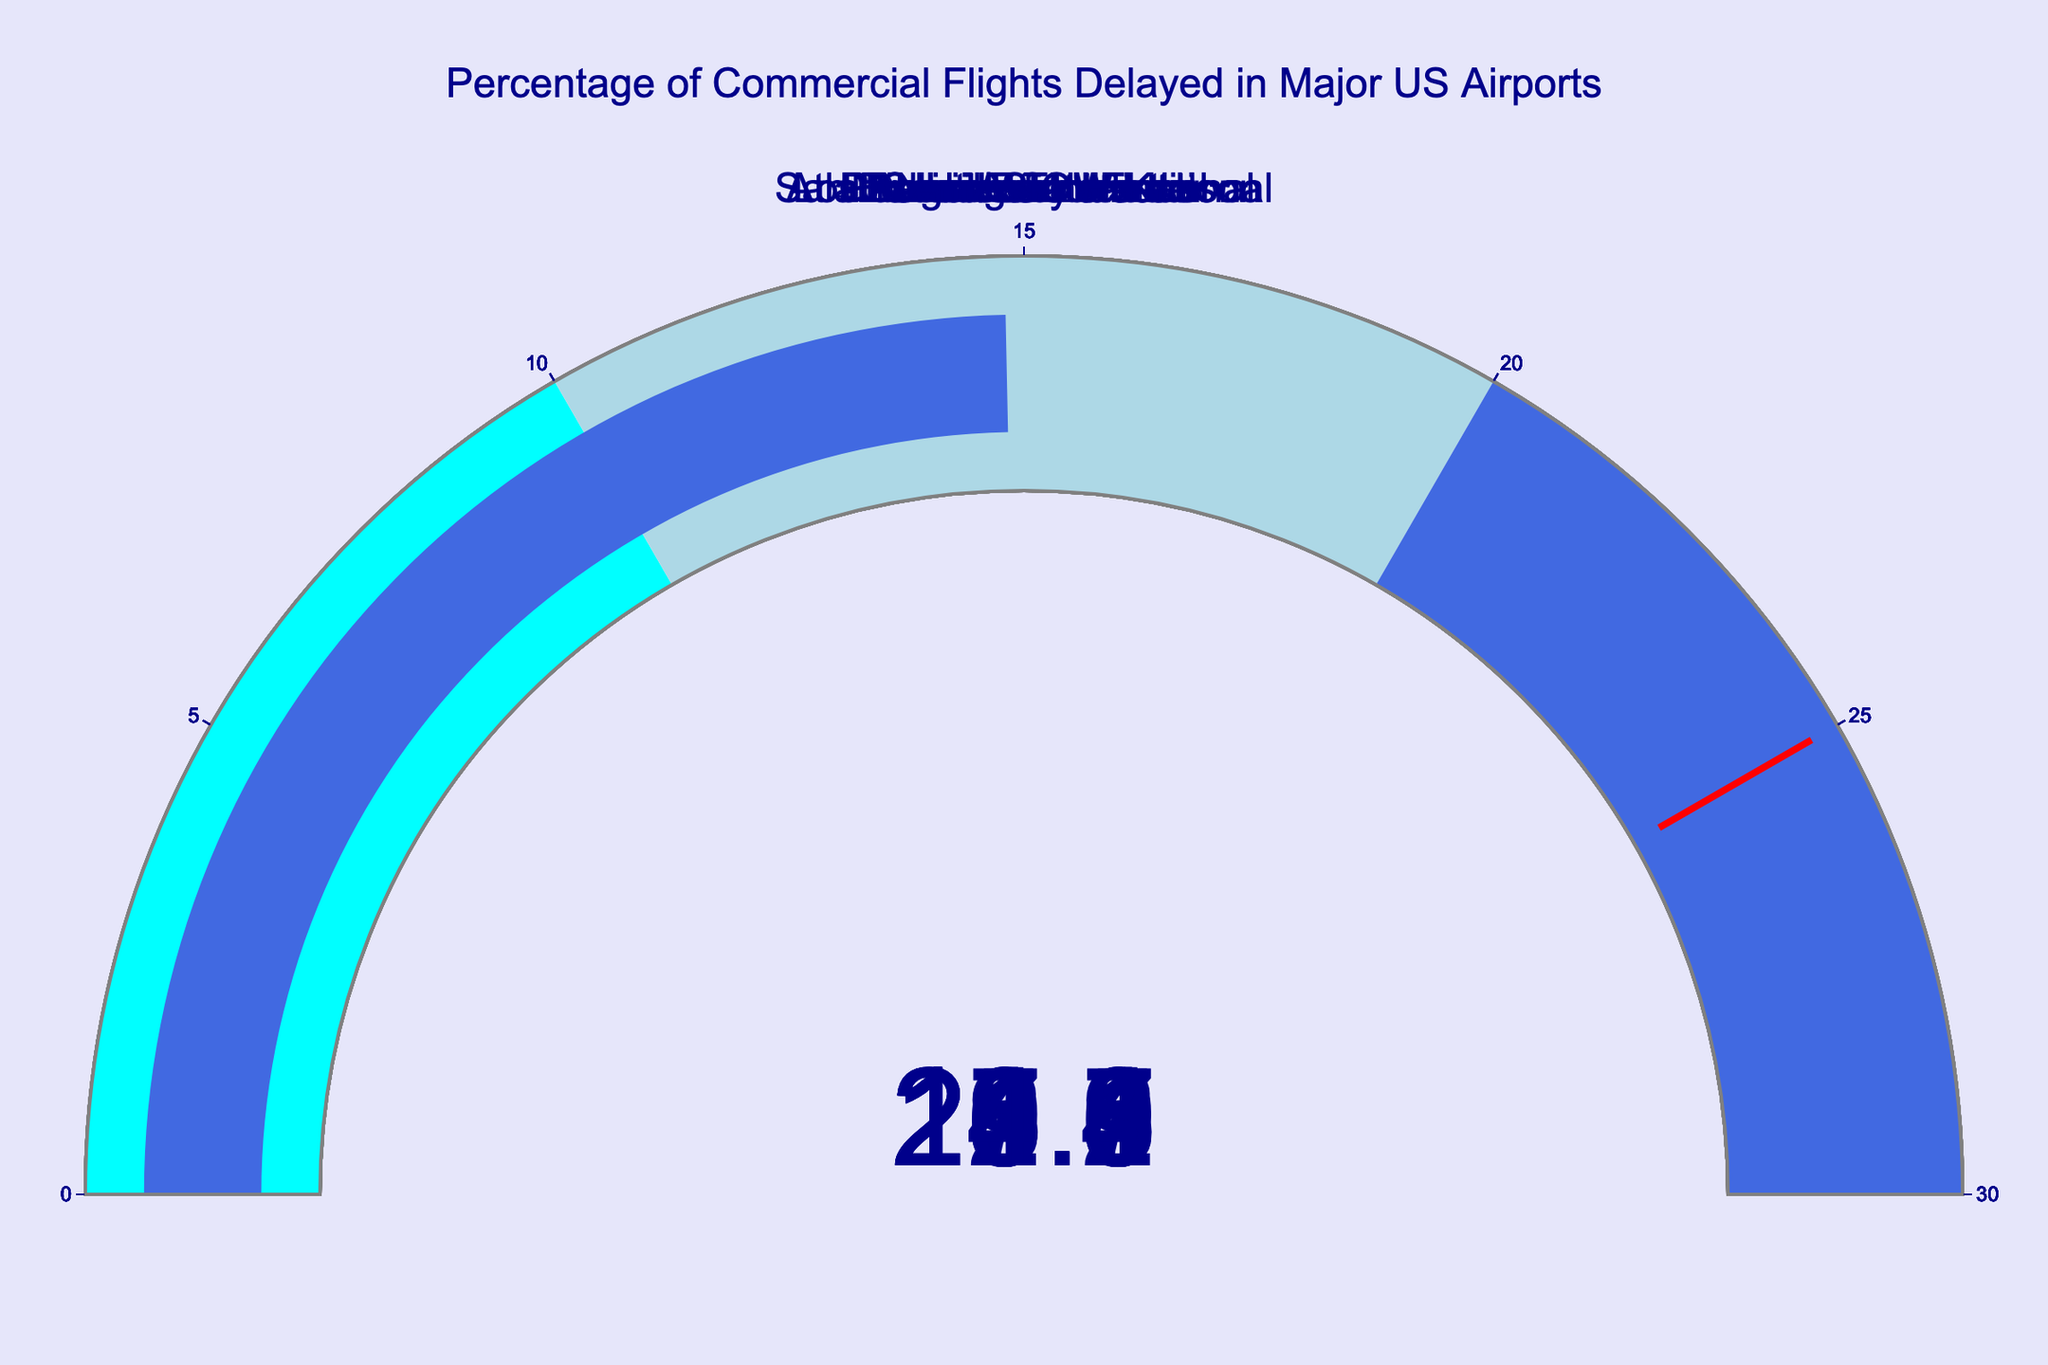What's the title of the chart? The title is prominently displayed above the gauges and indicates the overall topic of the chart. The text is "Percentage of Commercial Flights Delayed in Major US Airports" as shown in the title section of the figure.
Answer: Percentage of Commercial Flights Delayed in Major US Airports How many airports are represented in the chart? There are gauges for each airport, and you can count them directly from the figure. Each gauge represents one airport. By counting these gauges, you find there are 10 airports.
Answer: 10 Which airport has the highest percentage of delays? By looking at all the gauges, you can identify the highest value displayed on any gauge. The highest percentage shown is 23.6%, which corresponds to New York JFK.
Answer: New York JFK Which airport has the lowest percentage of delays? Similar to the previous question, observe all the gauges and identify the lowest value displayed. The lowest percentage is 14.8%, which belongs to Phoenix Sky Harbor.
Answer: Phoenix Sky Harbor What is the average delay percentage across all the airports? To find the average, sum the delay percentages of all 10 airports and then divide by 10. The total is 18.5 + 22.3 + 15.7 + 19.8 + 17.2 + 20.1 + 23.6 + 16.4 + 21.9 + 14.8 = 190.3. So the average is 190.3 / 10 = 19.03.
Answer: 19.03 How many airports have delay percentages above 20%? Identify each gauge that shows a delay percentage greater than 20%. These include Chicago O'Hare (22.3%), San Francisco International (20.1%), New York JFK (23.6%), and Miami International (21.9%). There are 4 such airports.
Answer: 4 What is the range of delay percentages observed in the chart? The range is calculated by finding the difference between the maximum and minimum delay percentages. The maximum is 23.6% (New York JFK) and the minimum is 14.8% (Phoenix Sky Harbor). So the range is 23.6% - 14.8% = 8.8%.
Answer: 8.8% Which airports have a delay percentage closest to the average? First calculate the average delay percentage (19.03%). Then, find the airport(s) whose delays are closest to this average. Denver International has a delay percentage of 17.2%, and Dallas/Fort Worth has 19.8%. The closest is Dallas/Fort Worth with 19.8% which is 0.77% away from the average.
Answer: Dallas/Fort Worth What percentage of airports have delay percentages below 18%? Count the number of airports with delay percentages below 18%, and then divide by the total number of airports (10), and multiply by 100. The qualifying airports are Los Angeles International (15.7%), Denver International (17.2%), Seattle-Tacoma (16.4%), and Phoenix Sky Harbor (14.8%), making 4 out of 10 airports. Thus, the percentage is (4/10) * 100 = 40%.
Answer: 40% 